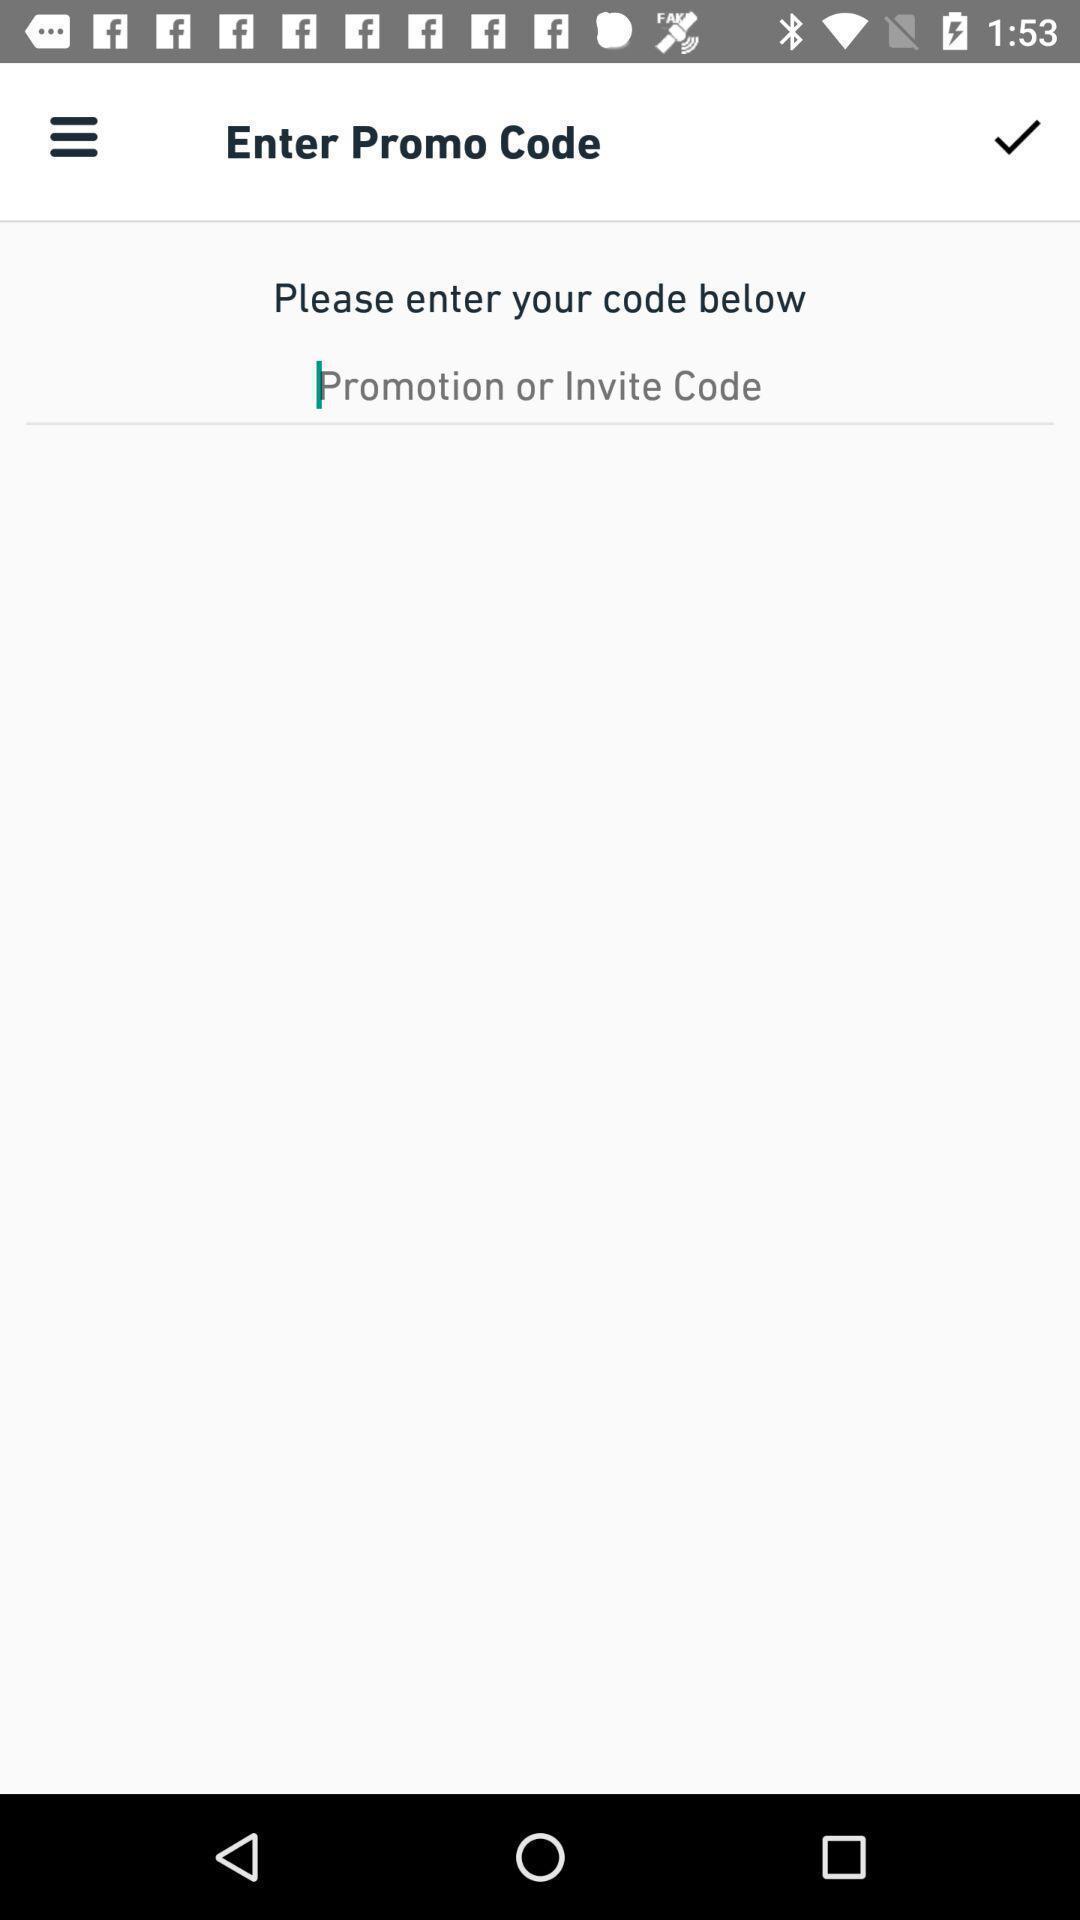Provide a description of this screenshot. Page to enter promo code for a food delivery app. 